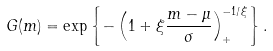Convert formula to latex. <formula><loc_0><loc_0><loc_500><loc_500>G ( m ) = \exp \left \{ - \left ( 1 + \xi \frac { m - \mu } { \sigma } \right ) _ { + } ^ { - 1 / \xi } \right \} .</formula> 